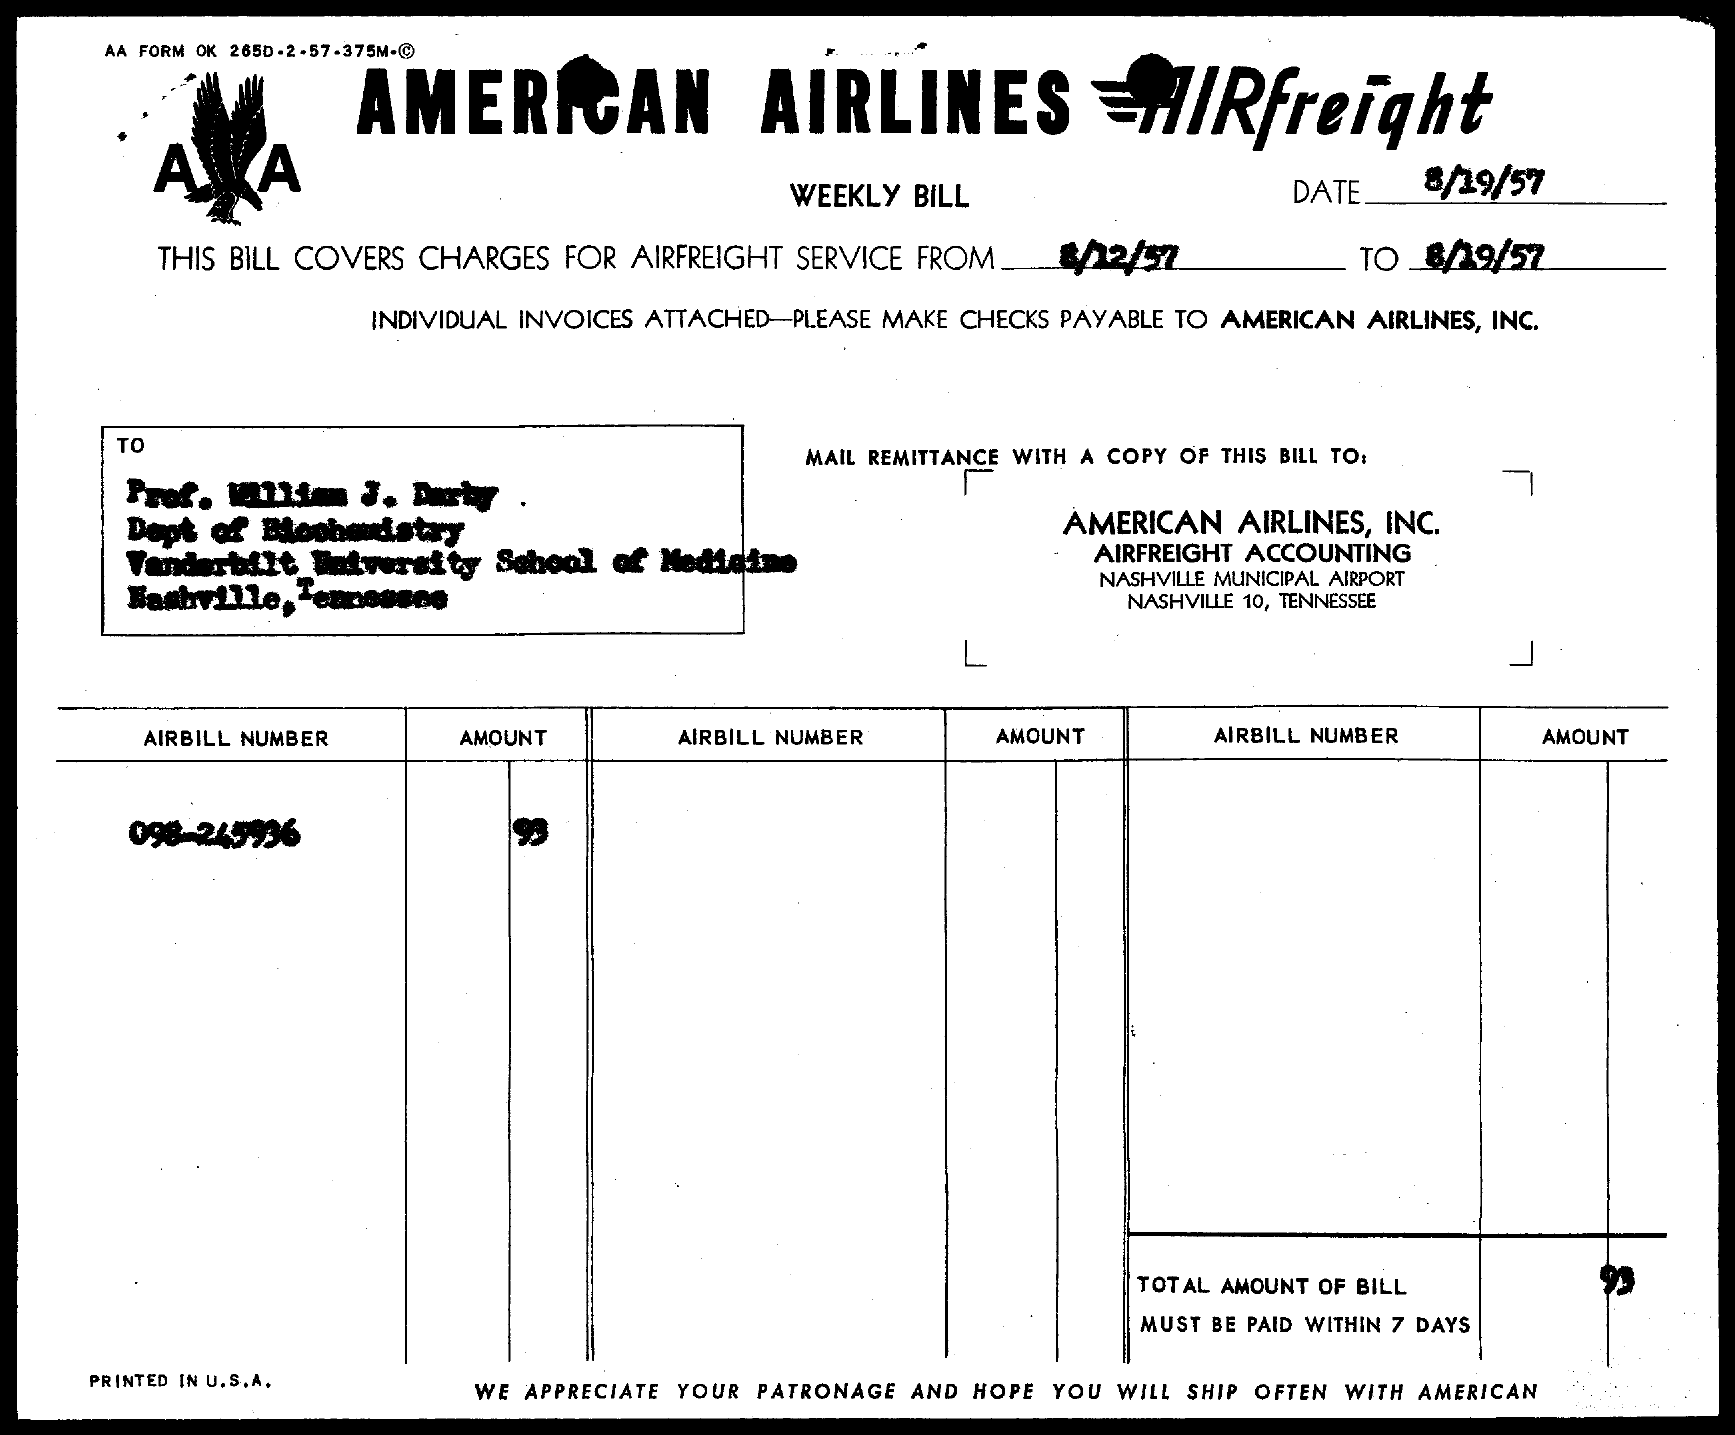Specify some key components in this picture. The total amount of the bill is 93 dollars. The AirBill Number is 098-245936. 